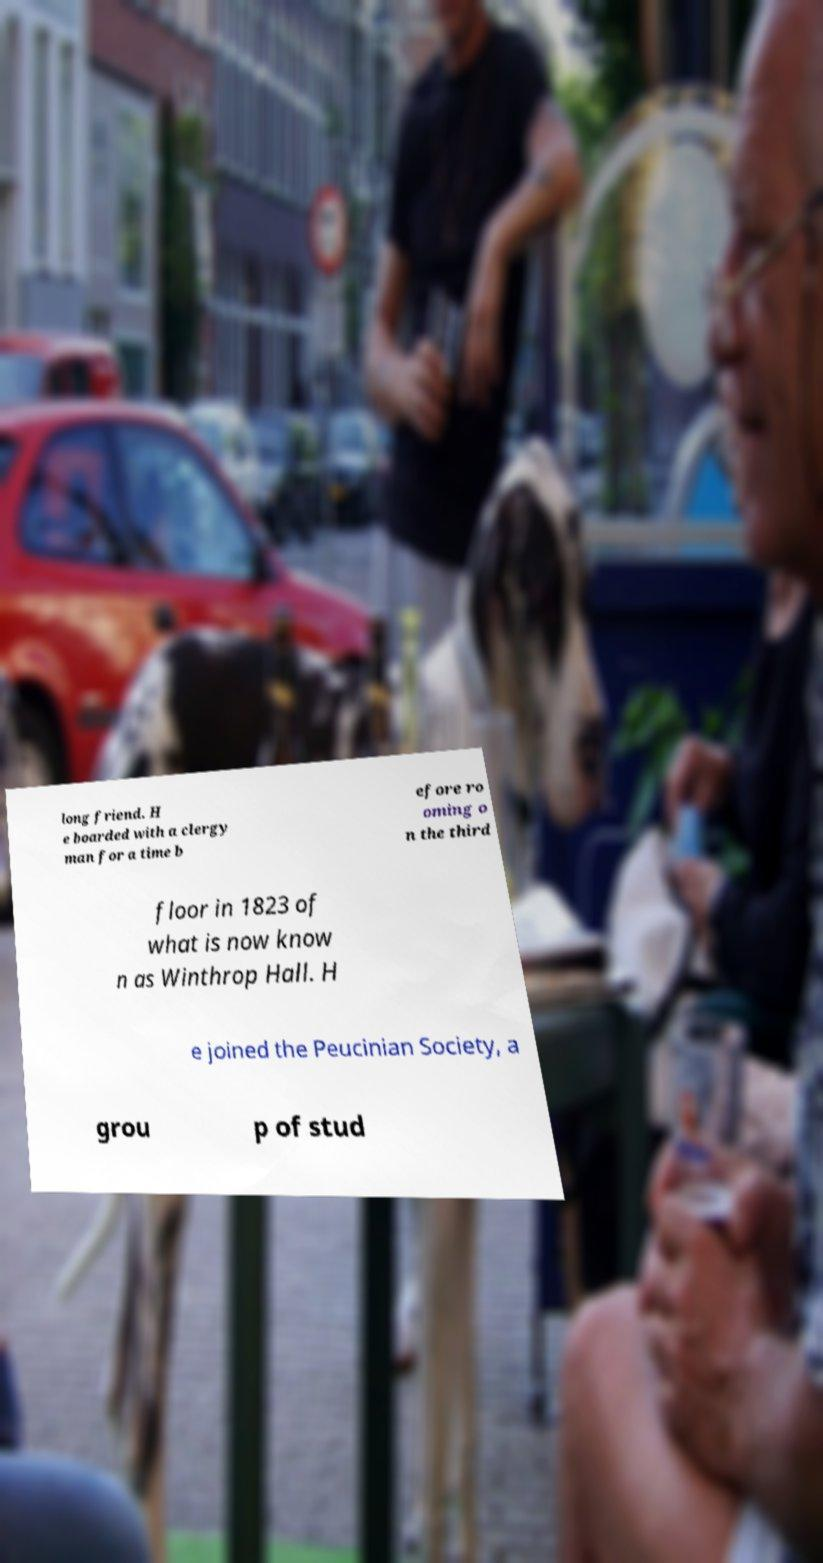Can you read and provide the text displayed in the image?This photo seems to have some interesting text. Can you extract and type it out for me? long friend. H e boarded with a clergy man for a time b efore ro oming o n the third floor in 1823 of what is now know n as Winthrop Hall. H e joined the Peucinian Society, a grou p of stud 